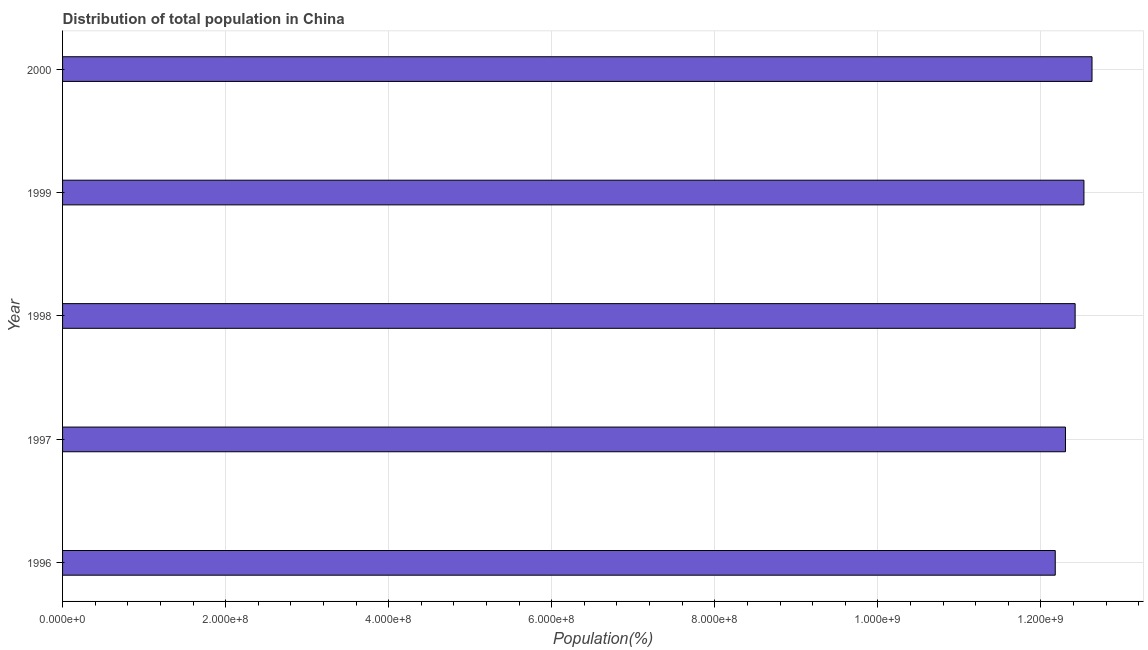What is the title of the graph?
Provide a short and direct response. Distribution of total population in China . What is the label or title of the X-axis?
Give a very brief answer. Population(%). What is the label or title of the Y-axis?
Ensure brevity in your answer.  Year. What is the population in 1997?
Your answer should be compact. 1.23e+09. Across all years, what is the maximum population?
Provide a short and direct response. 1.26e+09. Across all years, what is the minimum population?
Your answer should be compact. 1.22e+09. In which year was the population maximum?
Provide a short and direct response. 2000. In which year was the population minimum?
Provide a succinct answer. 1996. What is the sum of the population?
Provide a short and direct response. 6.20e+09. What is the difference between the population in 1996 and 2000?
Offer a terse response. -4.51e+07. What is the average population per year?
Provide a succinct answer. 1.24e+09. What is the median population?
Provide a succinct answer. 1.24e+09. In how many years, is the population greater than 560000000 %?
Your answer should be very brief. 5. Do a majority of the years between 1999 and 2000 (inclusive) have population greater than 360000000 %?
Keep it short and to the point. Yes. What is the difference between the highest and the second highest population?
Offer a terse response. 9.91e+06. What is the difference between the highest and the lowest population?
Give a very brief answer. 4.51e+07. In how many years, is the population greater than the average population taken over all years?
Your answer should be compact. 3. How many bars are there?
Provide a succinct answer. 5. How many years are there in the graph?
Offer a terse response. 5. Are the values on the major ticks of X-axis written in scientific E-notation?
Give a very brief answer. Yes. What is the Population(%) of 1996?
Offer a terse response. 1.22e+09. What is the Population(%) of 1997?
Ensure brevity in your answer.  1.23e+09. What is the Population(%) in 1998?
Give a very brief answer. 1.24e+09. What is the Population(%) of 1999?
Keep it short and to the point. 1.25e+09. What is the Population(%) in 2000?
Your response must be concise. 1.26e+09. What is the difference between the Population(%) in 1996 and 1997?
Keep it short and to the point. -1.25e+07. What is the difference between the Population(%) in 1996 and 1998?
Provide a succinct answer. -2.44e+07. What is the difference between the Population(%) in 1996 and 1999?
Make the answer very short. -3.52e+07. What is the difference between the Population(%) in 1996 and 2000?
Your response must be concise. -4.51e+07. What is the difference between the Population(%) in 1997 and 1998?
Give a very brief answer. -1.19e+07. What is the difference between the Population(%) in 1997 and 1999?
Your answer should be very brief. -2.27e+07. What is the difference between the Population(%) in 1997 and 2000?
Offer a very short reply. -3.26e+07. What is the difference between the Population(%) in 1998 and 1999?
Ensure brevity in your answer.  -1.08e+07. What is the difference between the Population(%) in 1998 and 2000?
Give a very brief answer. -2.07e+07. What is the difference between the Population(%) in 1999 and 2000?
Your response must be concise. -9.91e+06. What is the ratio of the Population(%) in 1996 to that in 1997?
Your answer should be compact. 0.99. What is the ratio of the Population(%) in 1997 to that in 1999?
Give a very brief answer. 0.98. What is the ratio of the Population(%) in 1997 to that in 2000?
Your response must be concise. 0.97. What is the ratio of the Population(%) in 1998 to that in 1999?
Give a very brief answer. 0.99. What is the ratio of the Population(%) in 1998 to that in 2000?
Provide a short and direct response. 0.98. 